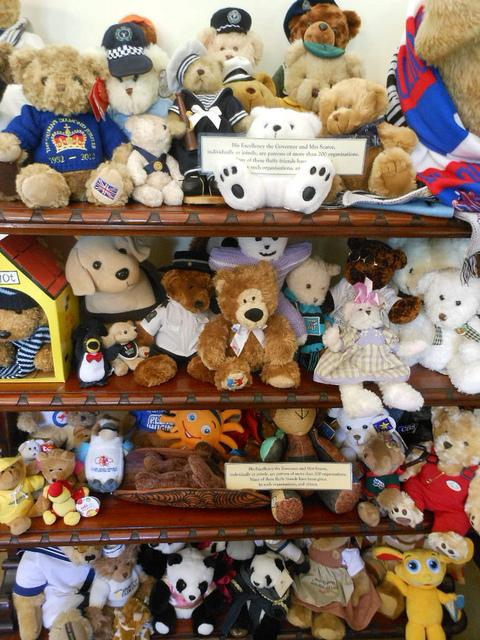What does the person who owns the shelves like to collect? Please explain your reasoning. stuffed animals. The abundance of answer a visible on the shelves implies the owner is interested in collecting the items depicted. 